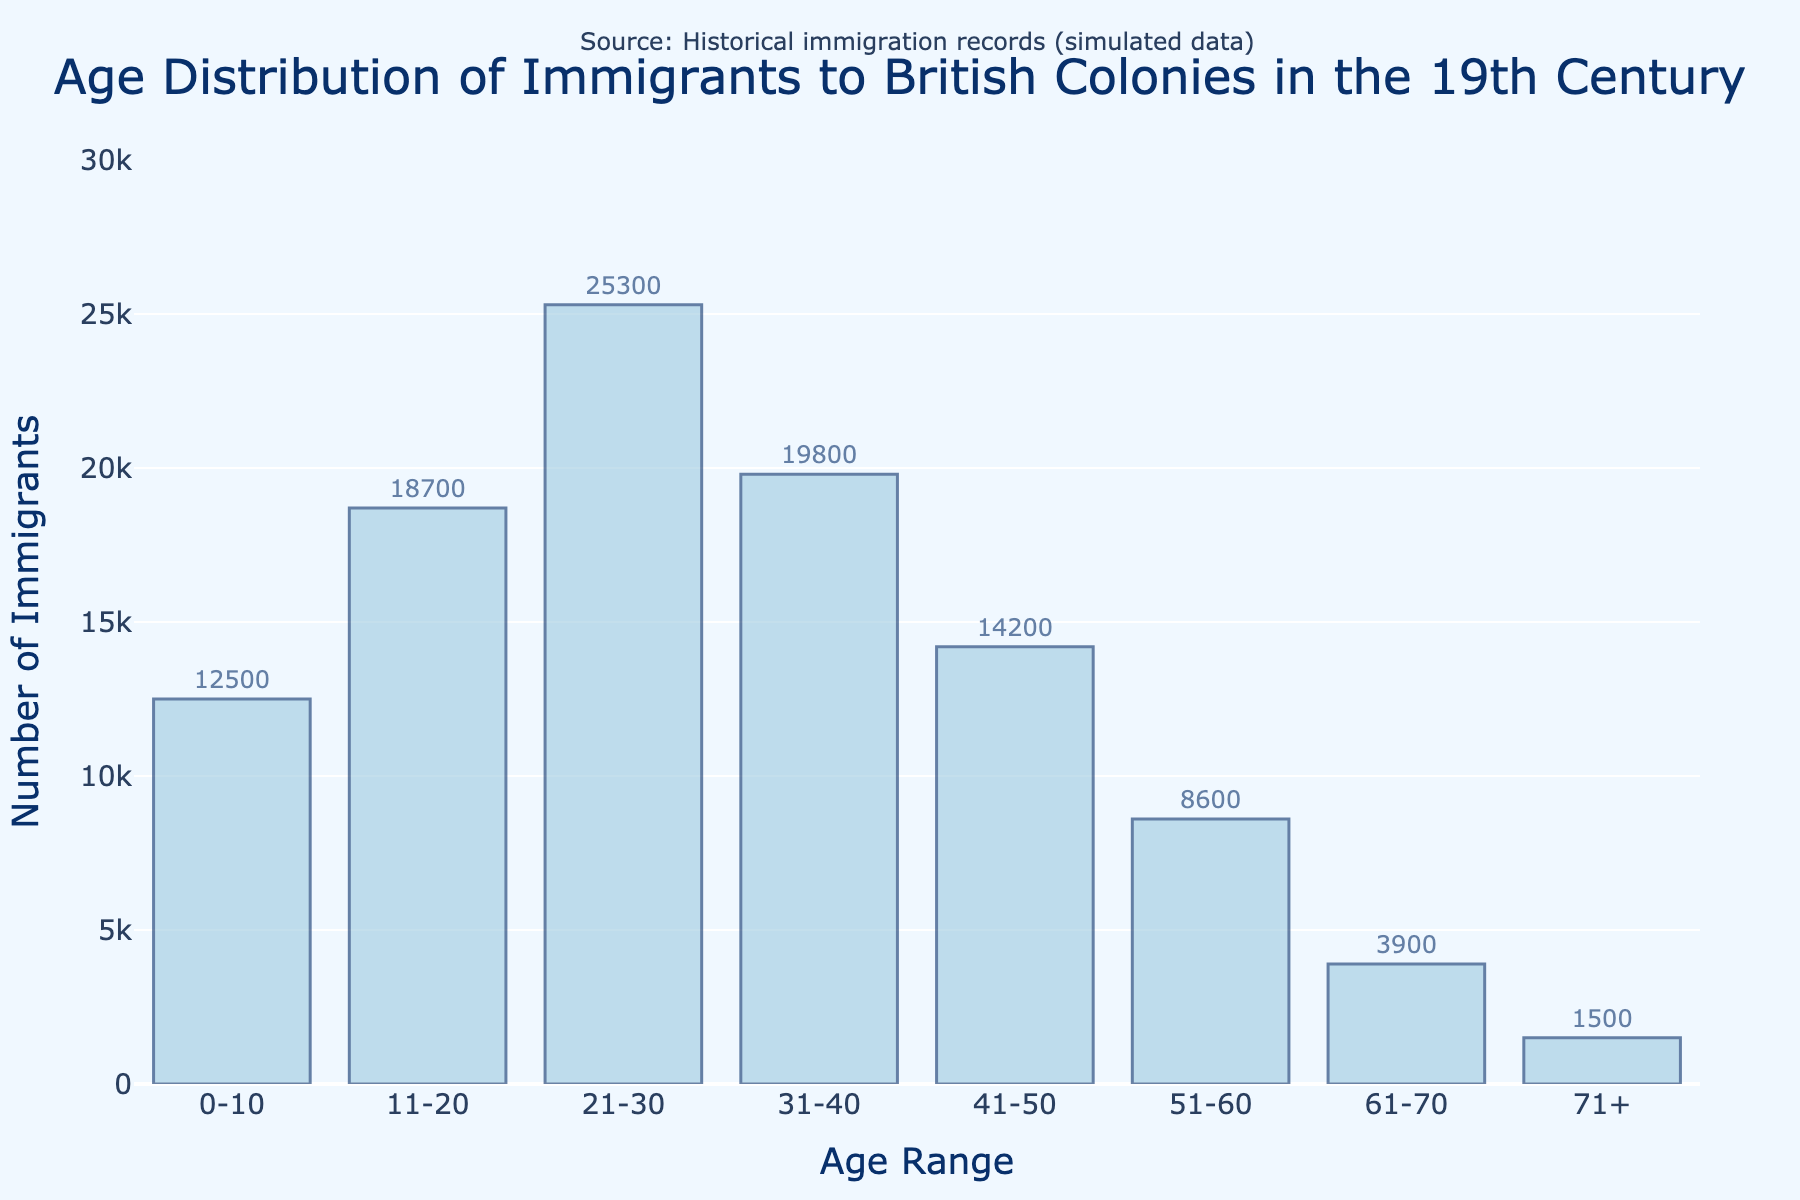What's the title of the plot? The title is located at the top center of the plot. It summarizes the content and purpose of the plot.
Answer: Age Distribution of Immigrants to British Colonies in the 19th Century What is the range of numbers on the y-axis? The y-axis represents the number of immigrants and is scaled to accommodate the data points. The range is from 0 to 30,000 based on the largest data value represented.
Answer: 0 to 30,000 Which age range has the highest number of immigrants? By inspecting the height of the bars, which represent the number of immigrants, the tallest bar corresponds to the age range with the most immigrants.
Answer: 21-30 Compare the number of immigrants in the age groups 21-30 and 31-40. Which has more and by how much? Check the heights of the bars for the two age ranges. The value for 21-30 is 25,300 and for 31-40 is 19,800. Subtract to find the difference. 25,300 - 19,800 = 5,500.
Answer: The age range 21-30 has 5,500 more immigrants than 31-40 What proportion of the total immigrants are aged 11-20? To find the proportion, divide the number of immigrants aged 11-20 by the total number of immigrants, then multiply by 100 for the percentage. The total number of immigrants is the sum of all data points: 12,500 + 18,700 + 25,300 + 19,800 + 14,200 + 8,600 + 3,900 + 1,500 = 104,500. So, (18,700 / 104,500) * 100 ≈ 17.9%.
Answer: 17.9% How does the number of immigrants aged 0-10 compare to those aged 51-60? Compare the heights of the bars. The value for 0-10 is 12,500 and for 51-60 is 8,600. 12,500 is more than 8,600.
Answer: 0-10 has more immigrants than 51-60 What is the total number of immigrants aged 41 and above? Sum the number of immigrants in the age ranges 41-50, 51-60, 61-70, and 71+. Add 14,200 + 8,600 + 3,900 + 1,500 = 28,200.
Answer: 28,200 Which age group shows the least number of immigrants? Observe the shortest bar in the histogram. The shortest bar represents the age range with the least number of immigrants.
Answer: 71+ What can be inferred about the general trend in the age distribution of immigrants? By looking at the bar heights, we note that the number of immigrants starts relatively high, increases to peak at 21-30, then generally declines. This pattern suggests heavier immigration in younger age groups with fewer older immigrants.
Answer: The number of immigrants declines with age after peaking at 21-30 What is the difference between the number of immigrants aged 11-20 and those aged 51-60? Subtract the number of immigrants of the latter group from the former. That is 18,700 - 8,600 = 10,100.
Answer: 10,100 